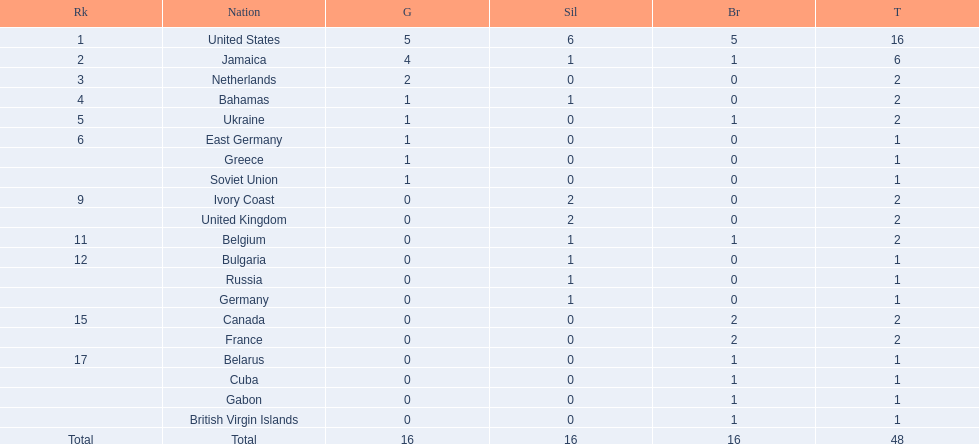Which countries competed in the 60 meters competition? United States, Jamaica, Netherlands, Bahamas, Ukraine, East Germany, Greece, Soviet Union, Ivory Coast, United Kingdom, Belgium, Bulgaria, Russia, Germany, Canada, France, Belarus, Cuba, Gabon, British Virgin Islands. And how many gold medals did they win? 5, 4, 2, 1, 1, 1, 1, 1, 0, 0, 0, 0, 0, 0, 0, 0, 0, 0, 0, 0. Of those countries, which won the second highest number gold medals? Jamaica. 